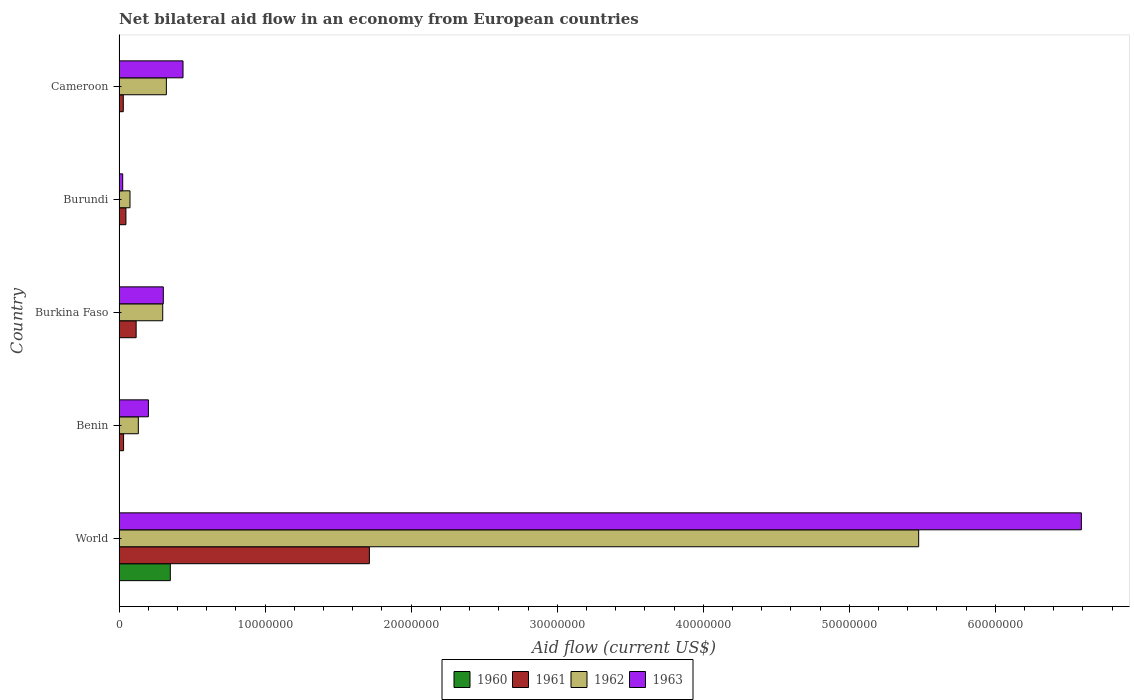How many different coloured bars are there?
Offer a terse response. 4. Are the number of bars per tick equal to the number of legend labels?
Keep it short and to the point. Yes. Are the number of bars on each tick of the Y-axis equal?
Provide a succinct answer. Yes. What is the label of the 1st group of bars from the top?
Your answer should be compact. Cameroon. In how many cases, is the number of bars for a given country not equal to the number of legend labels?
Provide a short and direct response. 0. What is the net bilateral aid flow in 1961 in World?
Your response must be concise. 1.71e+07. Across all countries, what is the maximum net bilateral aid flow in 1960?
Give a very brief answer. 3.51e+06. Across all countries, what is the minimum net bilateral aid flow in 1962?
Ensure brevity in your answer.  7.50e+05. In which country was the net bilateral aid flow in 1961 minimum?
Offer a very short reply. Cameroon. What is the total net bilateral aid flow in 1960 in the graph?
Offer a very short reply. 3.56e+06. What is the difference between the net bilateral aid flow in 1960 in Burundi and that in Cameroon?
Your response must be concise. -10000. What is the difference between the net bilateral aid flow in 1963 in Cameroon and the net bilateral aid flow in 1960 in Benin?
Offer a very short reply. 4.37e+06. What is the average net bilateral aid flow in 1963 per country?
Your answer should be very brief. 1.51e+07. What is the difference between the net bilateral aid flow in 1961 and net bilateral aid flow in 1960 in Burundi?
Provide a succinct answer. 4.60e+05. What is the ratio of the net bilateral aid flow in 1962 in Benin to that in World?
Make the answer very short. 0.02. Is the difference between the net bilateral aid flow in 1961 in Benin and Burkina Faso greater than the difference between the net bilateral aid flow in 1960 in Benin and Burkina Faso?
Provide a short and direct response. No. What is the difference between the highest and the second highest net bilateral aid flow in 1961?
Keep it short and to the point. 1.60e+07. What is the difference between the highest and the lowest net bilateral aid flow in 1960?
Your response must be concise. 3.50e+06. Is it the case that in every country, the sum of the net bilateral aid flow in 1962 and net bilateral aid flow in 1960 is greater than the sum of net bilateral aid flow in 1963 and net bilateral aid flow in 1961?
Your answer should be compact. Yes. Is it the case that in every country, the sum of the net bilateral aid flow in 1961 and net bilateral aid flow in 1962 is greater than the net bilateral aid flow in 1963?
Your response must be concise. No. How many bars are there?
Offer a very short reply. 20. What is the difference between two consecutive major ticks on the X-axis?
Offer a very short reply. 1.00e+07. Does the graph contain any zero values?
Your response must be concise. No. Does the graph contain grids?
Your response must be concise. No. Where does the legend appear in the graph?
Keep it short and to the point. Bottom center. How are the legend labels stacked?
Provide a short and direct response. Horizontal. What is the title of the graph?
Give a very brief answer. Net bilateral aid flow in an economy from European countries. Does "1993" appear as one of the legend labels in the graph?
Ensure brevity in your answer.  No. What is the Aid flow (current US$) of 1960 in World?
Provide a succinct answer. 3.51e+06. What is the Aid flow (current US$) in 1961 in World?
Keep it short and to the point. 1.71e+07. What is the Aid flow (current US$) in 1962 in World?
Provide a short and direct response. 5.48e+07. What is the Aid flow (current US$) of 1963 in World?
Make the answer very short. 6.59e+07. What is the Aid flow (current US$) in 1961 in Benin?
Your answer should be very brief. 3.10e+05. What is the Aid flow (current US$) of 1962 in Benin?
Provide a short and direct response. 1.32e+06. What is the Aid flow (current US$) in 1963 in Benin?
Offer a terse response. 2.01e+06. What is the Aid flow (current US$) in 1961 in Burkina Faso?
Offer a terse response. 1.17e+06. What is the Aid flow (current US$) of 1962 in Burkina Faso?
Provide a succinct answer. 2.99e+06. What is the Aid flow (current US$) of 1963 in Burkina Faso?
Give a very brief answer. 3.03e+06. What is the Aid flow (current US$) of 1960 in Burundi?
Your answer should be very brief. 10000. What is the Aid flow (current US$) in 1961 in Burundi?
Provide a succinct answer. 4.70e+05. What is the Aid flow (current US$) of 1962 in Burundi?
Ensure brevity in your answer.  7.50e+05. What is the Aid flow (current US$) in 1960 in Cameroon?
Your answer should be compact. 2.00e+04. What is the Aid flow (current US$) in 1962 in Cameroon?
Ensure brevity in your answer.  3.24e+06. What is the Aid flow (current US$) in 1963 in Cameroon?
Your response must be concise. 4.38e+06. Across all countries, what is the maximum Aid flow (current US$) in 1960?
Your answer should be very brief. 3.51e+06. Across all countries, what is the maximum Aid flow (current US$) in 1961?
Your answer should be compact. 1.71e+07. Across all countries, what is the maximum Aid flow (current US$) of 1962?
Keep it short and to the point. 5.48e+07. Across all countries, what is the maximum Aid flow (current US$) of 1963?
Keep it short and to the point. 6.59e+07. Across all countries, what is the minimum Aid flow (current US$) of 1961?
Offer a terse response. 2.90e+05. Across all countries, what is the minimum Aid flow (current US$) in 1962?
Your answer should be compact. 7.50e+05. What is the total Aid flow (current US$) of 1960 in the graph?
Keep it short and to the point. 3.56e+06. What is the total Aid flow (current US$) in 1961 in the graph?
Your answer should be very brief. 1.94e+07. What is the total Aid flow (current US$) of 1962 in the graph?
Ensure brevity in your answer.  6.30e+07. What is the total Aid flow (current US$) of 1963 in the graph?
Ensure brevity in your answer.  7.56e+07. What is the difference between the Aid flow (current US$) in 1960 in World and that in Benin?
Your response must be concise. 3.50e+06. What is the difference between the Aid flow (current US$) in 1961 in World and that in Benin?
Provide a short and direct response. 1.68e+07. What is the difference between the Aid flow (current US$) of 1962 in World and that in Benin?
Make the answer very short. 5.34e+07. What is the difference between the Aid flow (current US$) of 1963 in World and that in Benin?
Ensure brevity in your answer.  6.39e+07. What is the difference between the Aid flow (current US$) in 1960 in World and that in Burkina Faso?
Provide a succinct answer. 3.50e+06. What is the difference between the Aid flow (current US$) in 1961 in World and that in Burkina Faso?
Provide a succinct answer. 1.60e+07. What is the difference between the Aid flow (current US$) of 1962 in World and that in Burkina Faso?
Ensure brevity in your answer.  5.18e+07. What is the difference between the Aid flow (current US$) in 1963 in World and that in Burkina Faso?
Ensure brevity in your answer.  6.29e+07. What is the difference between the Aid flow (current US$) of 1960 in World and that in Burundi?
Ensure brevity in your answer.  3.50e+06. What is the difference between the Aid flow (current US$) in 1961 in World and that in Burundi?
Offer a terse response. 1.67e+07. What is the difference between the Aid flow (current US$) in 1962 in World and that in Burundi?
Ensure brevity in your answer.  5.40e+07. What is the difference between the Aid flow (current US$) in 1963 in World and that in Burundi?
Your answer should be very brief. 6.56e+07. What is the difference between the Aid flow (current US$) in 1960 in World and that in Cameroon?
Make the answer very short. 3.49e+06. What is the difference between the Aid flow (current US$) of 1961 in World and that in Cameroon?
Provide a short and direct response. 1.68e+07. What is the difference between the Aid flow (current US$) in 1962 in World and that in Cameroon?
Your answer should be very brief. 5.15e+07. What is the difference between the Aid flow (current US$) in 1963 in World and that in Cameroon?
Provide a short and direct response. 6.15e+07. What is the difference between the Aid flow (current US$) in 1960 in Benin and that in Burkina Faso?
Keep it short and to the point. 0. What is the difference between the Aid flow (current US$) of 1961 in Benin and that in Burkina Faso?
Give a very brief answer. -8.60e+05. What is the difference between the Aid flow (current US$) in 1962 in Benin and that in Burkina Faso?
Offer a very short reply. -1.67e+06. What is the difference between the Aid flow (current US$) of 1963 in Benin and that in Burkina Faso?
Keep it short and to the point. -1.02e+06. What is the difference between the Aid flow (current US$) of 1962 in Benin and that in Burundi?
Your answer should be compact. 5.70e+05. What is the difference between the Aid flow (current US$) of 1963 in Benin and that in Burundi?
Keep it short and to the point. 1.76e+06. What is the difference between the Aid flow (current US$) of 1960 in Benin and that in Cameroon?
Give a very brief answer. -10000. What is the difference between the Aid flow (current US$) of 1961 in Benin and that in Cameroon?
Give a very brief answer. 2.00e+04. What is the difference between the Aid flow (current US$) in 1962 in Benin and that in Cameroon?
Provide a short and direct response. -1.92e+06. What is the difference between the Aid flow (current US$) in 1963 in Benin and that in Cameroon?
Provide a short and direct response. -2.37e+06. What is the difference between the Aid flow (current US$) of 1961 in Burkina Faso and that in Burundi?
Provide a short and direct response. 7.00e+05. What is the difference between the Aid flow (current US$) of 1962 in Burkina Faso and that in Burundi?
Your response must be concise. 2.24e+06. What is the difference between the Aid flow (current US$) in 1963 in Burkina Faso and that in Burundi?
Keep it short and to the point. 2.78e+06. What is the difference between the Aid flow (current US$) in 1961 in Burkina Faso and that in Cameroon?
Offer a terse response. 8.80e+05. What is the difference between the Aid flow (current US$) of 1962 in Burkina Faso and that in Cameroon?
Give a very brief answer. -2.50e+05. What is the difference between the Aid flow (current US$) in 1963 in Burkina Faso and that in Cameroon?
Keep it short and to the point. -1.35e+06. What is the difference between the Aid flow (current US$) in 1961 in Burundi and that in Cameroon?
Give a very brief answer. 1.80e+05. What is the difference between the Aid flow (current US$) in 1962 in Burundi and that in Cameroon?
Offer a very short reply. -2.49e+06. What is the difference between the Aid flow (current US$) in 1963 in Burundi and that in Cameroon?
Your response must be concise. -4.13e+06. What is the difference between the Aid flow (current US$) in 1960 in World and the Aid flow (current US$) in 1961 in Benin?
Your response must be concise. 3.20e+06. What is the difference between the Aid flow (current US$) of 1960 in World and the Aid flow (current US$) of 1962 in Benin?
Your answer should be compact. 2.19e+06. What is the difference between the Aid flow (current US$) of 1960 in World and the Aid flow (current US$) of 1963 in Benin?
Offer a very short reply. 1.50e+06. What is the difference between the Aid flow (current US$) in 1961 in World and the Aid flow (current US$) in 1962 in Benin?
Your answer should be compact. 1.58e+07. What is the difference between the Aid flow (current US$) in 1961 in World and the Aid flow (current US$) in 1963 in Benin?
Your answer should be very brief. 1.51e+07. What is the difference between the Aid flow (current US$) of 1962 in World and the Aid flow (current US$) of 1963 in Benin?
Offer a very short reply. 5.27e+07. What is the difference between the Aid flow (current US$) of 1960 in World and the Aid flow (current US$) of 1961 in Burkina Faso?
Your answer should be compact. 2.34e+06. What is the difference between the Aid flow (current US$) in 1960 in World and the Aid flow (current US$) in 1962 in Burkina Faso?
Offer a terse response. 5.20e+05. What is the difference between the Aid flow (current US$) of 1961 in World and the Aid flow (current US$) of 1962 in Burkina Faso?
Your answer should be compact. 1.42e+07. What is the difference between the Aid flow (current US$) of 1961 in World and the Aid flow (current US$) of 1963 in Burkina Faso?
Offer a very short reply. 1.41e+07. What is the difference between the Aid flow (current US$) in 1962 in World and the Aid flow (current US$) in 1963 in Burkina Faso?
Your answer should be very brief. 5.17e+07. What is the difference between the Aid flow (current US$) of 1960 in World and the Aid flow (current US$) of 1961 in Burundi?
Your answer should be very brief. 3.04e+06. What is the difference between the Aid flow (current US$) of 1960 in World and the Aid flow (current US$) of 1962 in Burundi?
Offer a very short reply. 2.76e+06. What is the difference between the Aid flow (current US$) of 1960 in World and the Aid flow (current US$) of 1963 in Burundi?
Provide a succinct answer. 3.26e+06. What is the difference between the Aid flow (current US$) in 1961 in World and the Aid flow (current US$) in 1962 in Burundi?
Your answer should be very brief. 1.64e+07. What is the difference between the Aid flow (current US$) of 1961 in World and the Aid flow (current US$) of 1963 in Burundi?
Your response must be concise. 1.69e+07. What is the difference between the Aid flow (current US$) of 1962 in World and the Aid flow (current US$) of 1963 in Burundi?
Ensure brevity in your answer.  5.45e+07. What is the difference between the Aid flow (current US$) of 1960 in World and the Aid flow (current US$) of 1961 in Cameroon?
Provide a succinct answer. 3.22e+06. What is the difference between the Aid flow (current US$) in 1960 in World and the Aid flow (current US$) in 1962 in Cameroon?
Your response must be concise. 2.70e+05. What is the difference between the Aid flow (current US$) of 1960 in World and the Aid flow (current US$) of 1963 in Cameroon?
Provide a succinct answer. -8.70e+05. What is the difference between the Aid flow (current US$) in 1961 in World and the Aid flow (current US$) in 1962 in Cameroon?
Your answer should be compact. 1.39e+07. What is the difference between the Aid flow (current US$) in 1961 in World and the Aid flow (current US$) in 1963 in Cameroon?
Give a very brief answer. 1.28e+07. What is the difference between the Aid flow (current US$) of 1962 in World and the Aid flow (current US$) of 1963 in Cameroon?
Give a very brief answer. 5.04e+07. What is the difference between the Aid flow (current US$) of 1960 in Benin and the Aid flow (current US$) of 1961 in Burkina Faso?
Provide a succinct answer. -1.16e+06. What is the difference between the Aid flow (current US$) of 1960 in Benin and the Aid flow (current US$) of 1962 in Burkina Faso?
Make the answer very short. -2.98e+06. What is the difference between the Aid flow (current US$) in 1960 in Benin and the Aid flow (current US$) in 1963 in Burkina Faso?
Keep it short and to the point. -3.02e+06. What is the difference between the Aid flow (current US$) of 1961 in Benin and the Aid flow (current US$) of 1962 in Burkina Faso?
Offer a terse response. -2.68e+06. What is the difference between the Aid flow (current US$) of 1961 in Benin and the Aid flow (current US$) of 1963 in Burkina Faso?
Make the answer very short. -2.72e+06. What is the difference between the Aid flow (current US$) in 1962 in Benin and the Aid flow (current US$) in 1963 in Burkina Faso?
Give a very brief answer. -1.71e+06. What is the difference between the Aid flow (current US$) of 1960 in Benin and the Aid flow (current US$) of 1961 in Burundi?
Provide a short and direct response. -4.60e+05. What is the difference between the Aid flow (current US$) of 1960 in Benin and the Aid flow (current US$) of 1962 in Burundi?
Your response must be concise. -7.40e+05. What is the difference between the Aid flow (current US$) of 1961 in Benin and the Aid flow (current US$) of 1962 in Burundi?
Make the answer very short. -4.40e+05. What is the difference between the Aid flow (current US$) of 1961 in Benin and the Aid flow (current US$) of 1963 in Burundi?
Make the answer very short. 6.00e+04. What is the difference between the Aid flow (current US$) of 1962 in Benin and the Aid flow (current US$) of 1963 in Burundi?
Offer a very short reply. 1.07e+06. What is the difference between the Aid flow (current US$) in 1960 in Benin and the Aid flow (current US$) in 1961 in Cameroon?
Your answer should be compact. -2.80e+05. What is the difference between the Aid flow (current US$) in 1960 in Benin and the Aid flow (current US$) in 1962 in Cameroon?
Offer a very short reply. -3.23e+06. What is the difference between the Aid flow (current US$) of 1960 in Benin and the Aid flow (current US$) of 1963 in Cameroon?
Offer a very short reply. -4.37e+06. What is the difference between the Aid flow (current US$) in 1961 in Benin and the Aid flow (current US$) in 1962 in Cameroon?
Your answer should be compact. -2.93e+06. What is the difference between the Aid flow (current US$) in 1961 in Benin and the Aid flow (current US$) in 1963 in Cameroon?
Keep it short and to the point. -4.07e+06. What is the difference between the Aid flow (current US$) in 1962 in Benin and the Aid flow (current US$) in 1963 in Cameroon?
Provide a succinct answer. -3.06e+06. What is the difference between the Aid flow (current US$) in 1960 in Burkina Faso and the Aid flow (current US$) in 1961 in Burundi?
Give a very brief answer. -4.60e+05. What is the difference between the Aid flow (current US$) of 1960 in Burkina Faso and the Aid flow (current US$) of 1962 in Burundi?
Provide a short and direct response. -7.40e+05. What is the difference between the Aid flow (current US$) of 1961 in Burkina Faso and the Aid flow (current US$) of 1963 in Burundi?
Your answer should be very brief. 9.20e+05. What is the difference between the Aid flow (current US$) of 1962 in Burkina Faso and the Aid flow (current US$) of 1963 in Burundi?
Make the answer very short. 2.74e+06. What is the difference between the Aid flow (current US$) of 1960 in Burkina Faso and the Aid flow (current US$) of 1961 in Cameroon?
Offer a terse response. -2.80e+05. What is the difference between the Aid flow (current US$) in 1960 in Burkina Faso and the Aid flow (current US$) in 1962 in Cameroon?
Provide a short and direct response. -3.23e+06. What is the difference between the Aid flow (current US$) of 1960 in Burkina Faso and the Aid flow (current US$) of 1963 in Cameroon?
Your answer should be compact. -4.37e+06. What is the difference between the Aid flow (current US$) of 1961 in Burkina Faso and the Aid flow (current US$) of 1962 in Cameroon?
Offer a terse response. -2.07e+06. What is the difference between the Aid flow (current US$) in 1961 in Burkina Faso and the Aid flow (current US$) in 1963 in Cameroon?
Keep it short and to the point. -3.21e+06. What is the difference between the Aid flow (current US$) of 1962 in Burkina Faso and the Aid flow (current US$) of 1963 in Cameroon?
Your answer should be very brief. -1.39e+06. What is the difference between the Aid flow (current US$) in 1960 in Burundi and the Aid flow (current US$) in 1961 in Cameroon?
Give a very brief answer. -2.80e+05. What is the difference between the Aid flow (current US$) of 1960 in Burundi and the Aid flow (current US$) of 1962 in Cameroon?
Make the answer very short. -3.23e+06. What is the difference between the Aid flow (current US$) in 1960 in Burundi and the Aid flow (current US$) in 1963 in Cameroon?
Ensure brevity in your answer.  -4.37e+06. What is the difference between the Aid flow (current US$) of 1961 in Burundi and the Aid flow (current US$) of 1962 in Cameroon?
Provide a short and direct response. -2.77e+06. What is the difference between the Aid flow (current US$) of 1961 in Burundi and the Aid flow (current US$) of 1963 in Cameroon?
Make the answer very short. -3.91e+06. What is the difference between the Aid flow (current US$) in 1962 in Burundi and the Aid flow (current US$) in 1963 in Cameroon?
Offer a terse response. -3.63e+06. What is the average Aid flow (current US$) in 1960 per country?
Offer a terse response. 7.12e+05. What is the average Aid flow (current US$) of 1961 per country?
Offer a very short reply. 3.88e+06. What is the average Aid flow (current US$) of 1962 per country?
Your answer should be compact. 1.26e+07. What is the average Aid flow (current US$) of 1963 per country?
Your answer should be very brief. 1.51e+07. What is the difference between the Aid flow (current US$) of 1960 and Aid flow (current US$) of 1961 in World?
Your answer should be compact. -1.36e+07. What is the difference between the Aid flow (current US$) of 1960 and Aid flow (current US$) of 1962 in World?
Keep it short and to the point. -5.12e+07. What is the difference between the Aid flow (current US$) in 1960 and Aid flow (current US$) in 1963 in World?
Your response must be concise. -6.24e+07. What is the difference between the Aid flow (current US$) of 1961 and Aid flow (current US$) of 1962 in World?
Make the answer very short. -3.76e+07. What is the difference between the Aid flow (current US$) of 1961 and Aid flow (current US$) of 1963 in World?
Your response must be concise. -4.88e+07. What is the difference between the Aid flow (current US$) of 1962 and Aid flow (current US$) of 1963 in World?
Offer a very short reply. -1.11e+07. What is the difference between the Aid flow (current US$) in 1960 and Aid flow (current US$) in 1961 in Benin?
Your answer should be compact. -3.00e+05. What is the difference between the Aid flow (current US$) of 1960 and Aid flow (current US$) of 1962 in Benin?
Offer a very short reply. -1.31e+06. What is the difference between the Aid flow (current US$) of 1961 and Aid flow (current US$) of 1962 in Benin?
Your response must be concise. -1.01e+06. What is the difference between the Aid flow (current US$) in 1961 and Aid flow (current US$) in 1963 in Benin?
Your answer should be very brief. -1.70e+06. What is the difference between the Aid flow (current US$) in 1962 and Aid flow (current US$) in 1963 in Benin?
Ensure brevity in your answer.  -6.90e+05. What is the difference between the Aid flow (current US$) in 1960 and Aid flow (current US$) in 1961 in Burkina Faso?
Your answer should be very brief. -1.16e+06. What is the difference between the Aid flow (current US$) in 1960 and Aid flow (current US$) in 1962 in Burkina Faso?
Your answer should be very brief. -2.98e+06. What is the difference between the Aid flow (current US$) of 1960 and Aid flow (current US$) of 1963 in Burkina Faso?
Your answer should be compact. -3.02e+06. What is the difference between the Aid flow (current US$) of 1961 and Aid flow (current US$) of 1962 in Burkina Faso?
Provide a short and direct response. -1.82e+06. What is the difference between the Aid flow (current US$) in 1961 and Aid flow (current US$) in 1963 in Burkina Faso?
Provide a short and direct response. -1.86e+06. What is the difference between the Aid flow (current US$) in 1960 and Aid flow (current US$) in 1961 in Burundi?
Ensure brevity in your answer.  -4.60e+05. What is the difference between the Aid flow (current US$) of 1960 and Aid flow (current US$) of 1962 in Burundi?
Your response must be concise. -7.40e+05. What is the difference between the Aid flow (current US$) of 1960 and Aid flow (current US$) of 1963 in Burundi?
Give a very brief answer. -2.40e+05. What is the difference between the Aid flow (current US$) of 1961 and Aid flow (current US$) of 1962 in Burundi?
Provide a succinct answer. -2.80e+05. What is the difference between the Aid flow (current US$) of 1961 and Aid flow (current US$) of 1963 in Burundi?
Offer a terse response. 2.20e+05. What is the difference between the Aid flow (current US$) in 1960 and Aid flow (current US$) in 1962 in Cameroon?
Make the answer very short. -3.22e+06. What is the difference between the Aid flow (current US$) of 1960 and Aid flow (current US$) of 1963 in Cameroon?
Your answer should be compact. -4.36e+06. What is the difference between the Aid flow (current US$) of 1961 and Aid flow (current US$) of 1962 in Cameroon?
Offer a very short reply. -2.95e+06. What is the difference between the Aid flow (current US$) in 1961 and Aid flow (current US$) in 1963 in Cameroon?
Provide a short and direct response. -4.09e+06. What is the difference between the Aid flow (current US$) in 1962 and Aid flow (current US$) in 1963 in Cameroon?
Your response must be concise. -1.14e+06. What is the ratio of the Aid flow (current US$) in 1960 in World to that in Benin?
Give a very brief answer. 351. What is the ratio of the Aid flow (current US$) in 1961 in World to that in Benin?
Keep it short and to the point. 55.29. What is the ratio of the Aid flow (current US$) in 1962 in World to that in Benin?
Make the answer very short. 41.48. What is the ratio of the Aid flow (current US$) of 1963 in World to that in Benin?
Provide a short and direct response. 32.78. What is the ratio of the Aid flow (current US$) in 1960 in World to that in Burkina Faso?
Ensure brevity in your answer.  351. What is the ratio of the Aid flow (current US$) of 1961 in World to that in Burkina Faso?
Your response must be concise. 14.65. What is the ratio of the Aid flow (current US$) of 1962 in World to that in Burkina Faso?
Provide a short and direct response. 18.31. What is the ratio of the Aid flow (current US$) of 1963 in World to that in Burkina Faso?
Offer a very short reply. 21.75. What is the ratio of the Aid flow (current US$) of 1960 in World to that in Burundi?
Your answer should be very brief. 351. What is the ratio of the Aid flow (current US$) of 1961 in World to that in Burundi?
Offer a very short reply. 36.47. What is the ratio of the Aid flow (current US$) of 1963 in World to that in Burundi?
Provide a succinct answer. 263.56. What is the ratio of the Aid flow (current US$) of 1960 in World to that in Cameroon?
Make the answer very short. 175.5. What is the ratio of the Aid flow (current US$) in 1961 in World to that in Cameroon?
Offer a terse response. 59.1. What is the ratio of the Aid flow (current US$) in 1962 in World to that in Cameroon?
Your answer should be very brief. 16.9. What is the ratio of the Aid flow (current US$) of 1963 in World to that in Cameroon?
Make the answer very short. 15.04. What is the ratio of the Aid flow (current US$) in 1960 in Benin to that in Burkina Faso?
Make the answer very short. 1. What is the ratio of the Aid flow (current US$) of 1961 in Benin to that in Burkina Faso?
Offer a terse response. 0.27. What is the ratio of the Aid flow (current US$) in 1962 in Benin to that in Burkina Faso?
Your response must be concise. 0.44. What is the ratio of the Aid flow (current US$) in 1963 in Benin to that in Burkina Faso?
Your answer should be very brief. 0.66. What is the ratio of the Aid flow (current US$) of 1961 in Benin to that in Burundi?
Your response must be concise. 0.66. What is the ratio of the Aid flow (current US$) of 1962 in Benin to that in Burundi?
Provide a short and direct response. 1.76. What is the ratio of the Aid flow (current US$) in 1963 in Benin to that in Burundi?
Keep it short and to the point. 8.04. What is the ratio of the Aid flow (current US$) of 1961 in Benin to that in Cameroon?
Keep it short and to the point. 1.07. What is the ratio of the Aid flow (current US$) of 1962 in Benin to that in Cameroon?
Give a very brief answer. 0.41. What is the ratio of the Aid flow (current US$) of 1963 in Benin to that in Cameroon?
Your response must be concise. 0.46. What is the ratio of the Aid flow (current US$) of 1961 in Burkina Faso to that in Burundi?
Offer a terse response. 2.49. What is the ratio of the Aid flow (current US$) in 1962 in Burkina Faso to that in Burundi?
Provide a short and direct response. 3.99. What is the ratio of the Aid flow (current US$) in 1963 in Burkina Faso to that in Burundi?
Your answer should be compact. 12.12. What is the ratio of the Aid flow (current US$) in 1961 in Burkina Faso to that in Cameroon?
Give a very brief answer. 4.03. What is the ratio of the Aid flow (current US$) in 1962 in Burkina Faso to that in Cameroon?
Keep it short and to the point. 0.92. What is the ratio of the Aid flow (current US$) of 1963 in Burkina Faso to that in Cameroon?
Your answer should be very brief. 0.69. What is the ratio of the Aid flow (current US$) in 1960 in Burundi to that in Cameroon?
Your answer should be compact. 0.5. What is the ratio of the Aid flow (current US$) in 1961 in Burundi to that in Cameroon?
Provide a short and direct response. 1.62. What is the ratio of the Aid flow (current US$) in 1962 in Burundi to that in Cameroon?
Your answer should be compact. 0.23. What is the ratio of the Aid flow (current US$) in 1963 in Burundi to that in Cameroon?
Offer a terse response. 0.06. What is the difference between the highest and the second highest Aid flow (current US$) in 1960?
Offer a terse response. 3.49e+06. What is the difference between the highest and the second highest Aid flow (current US$) in 1961?
Offer a very short reply. 1.60e+07. What is the difference between the highest and the second highest Aid flow (current US$) of 1962?
Give a very brief answer. 5.15e+07. What is the difference between the highest and the second highest Aid flow (current US$) in 1963?
Your response must be concise. 6.15e+07. What is the difference between the highest and the lowest Aid flow (current US$) of 1960?
Provide a succinct answer. 3.50e+06. What is the difference between the highest and the lowest Aid flow (current US$) in 1961?
Make the answer very short. 1.68e+07. What is the difference between the highest and the lowest Aid flow (current US$) in 1962?
Offer a terse response. 5.40e+07. What is the difference between the highest and the lowest Aid flow (current US$) in 1963?
Provide a short and direct response. 6.56e+07. 